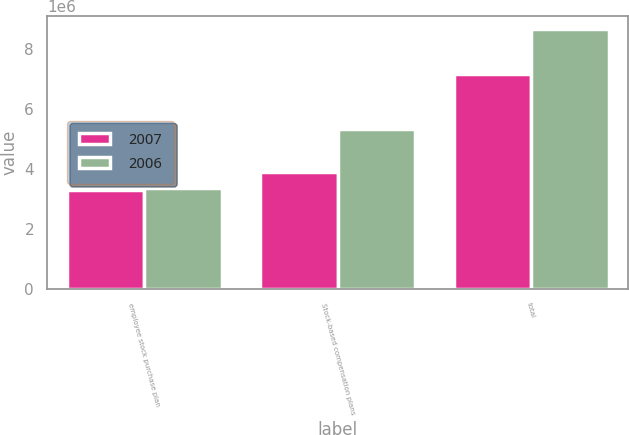Convert chart to OTSL. <chart><loc_0><loc_0><loc_500><loc_500><stacked_bar_chart><ecel><fcel>employee stock purchase plan<fcel>Stock-based compensation plans<fcel>total<nl><fcel>2007<fcel>3.27889e+06<fcel>3.8943e+06<fcel>7.17319e+06<nl><fcel>2006<fcel>3.34774e+06<fcel>5.31288e+06<fcel>8.66062e+06<nl></chart> 